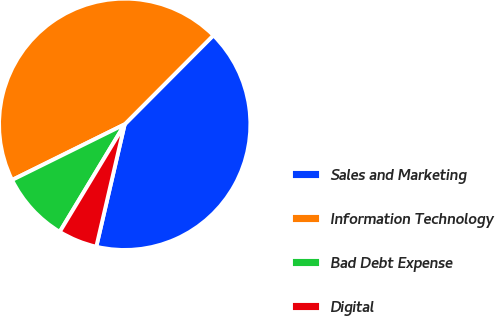Convert chart. <chart><loc_0><loc_0><loc_500><loc_500><pie_chart><fcel>Sales and Marketing<fcel>Information Technology<fcel>Bad Debt Expense<fcel>Digital<nl><fcel>41.16%<fcel>44.78%<fcel>9.04%<fcel>5.02%<nl></chart> 